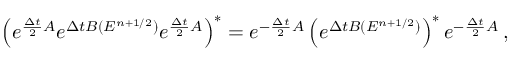<formula> <loc_0><loc_0><loc_500><loc_500>\left ( e ^ { \frac { \Delta t } { 2 } A } e ^ { \Delta t B ( E ^ { n + 1 / 2 } ) } e ^ { \frac { \Delta t } { 2 } A } \right ) ^ { * } = e ^ { - \frac { \Delta t } { 2 } A } \left ( e ^ { \Delta t B ( E ^ { n + 1 / 2 } ) } \right ) ^ { * } e ^ { - \frac { \Delta t } { 2 } A } \, ,</formula> 